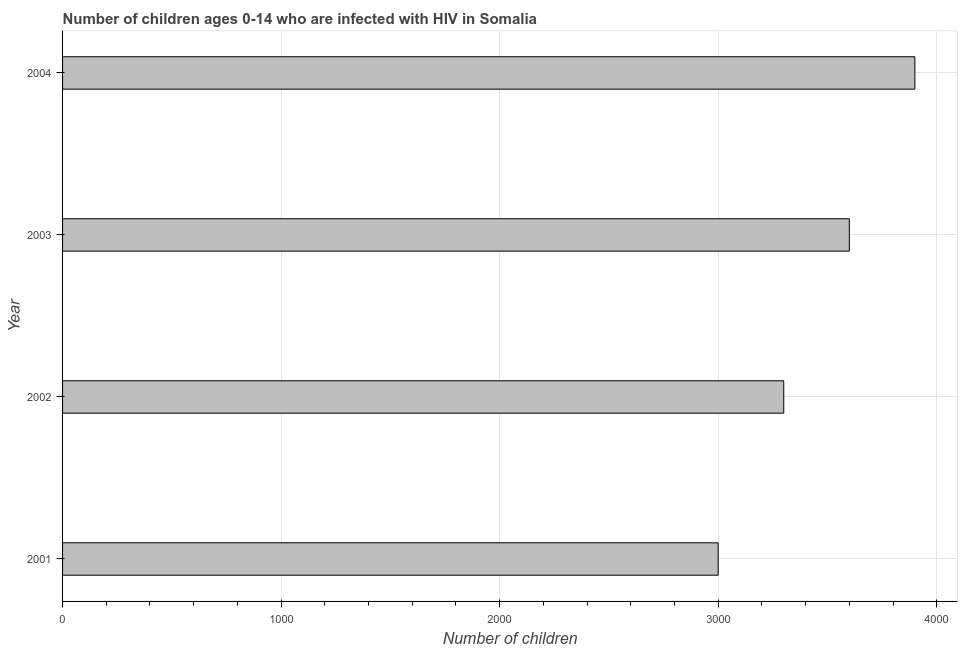Does the graph contain any zero values?
Provide a succinct answer. No. What is the title of the graph?
Ensure brevity in your answer.  Number of children ages 0-14 who are infected with HIV in Somalia. What is the label or title of the X-axis?
Ensure brevity in your answer.  Number of children. What is the label or title of the Y-axis?
Your answer should be compact. Year. What is the number of children living with hiv in 2001?
Keep it short and to the point. 3000. Across all years, what is the maximum number of children living with hiv?
Give a very brief answer. 3900. Across all years, what is the minimum number of children living with hiv?
Keep it short and to the point. 3000. What is the sum of the number of children living with hiv?
Keep it short and to the point. 1.38e+04. What is the difference between the number of children living with hiv in 2001 and 2004?
Give a very brief answer. -900. What is the average number of children living with hiv per year?
Make the answer very short. 3450. What is the median number of children living with hiv?
Ensure brevity in your answer.  3450. In how many years, is the number of children living with hiv greater than 200 ?
Your response must be concise. 4. What is the ratio of the number of children living with hiv in 2001 to that in 2002?
Provide a short and direct response. 0.91. What is the difference between the highest and the second highest number of children living with hiv?
Your answer should be compact. 300. Is the sum of the number of children living with hiv in 2002 and 2003 greater than the maximum number of children living with hiv across all years?
Give a very brief answer. Yes. What is the difference between the highest and the lowest number of children living with hiv?
Make the answer very short. 900. In how many years, is the number of children living with hiv greater than the average number of children living with hiv taken over all years?
Your answer should be very brief. 2. How many bars are there?
Your answer should be very brief. 4. Are all the bars in the graph horizontal?
Offer a terse response. Yes. How many years are there in the graph?
Your answer should be compact. 4. What is the Number of children of 2001?
Make the answer very short. 3000. What is the Number of children of 2002?
Your answer should be compact. 3300. What is the Number of children in 2003?
Give a very brief answer. 3600. What is the Number of children of 2004?
Keep it short and to the point. 3900. What is the difference between the Number of children in 2001 and 2002?
Make the answer very short. -300. What is the difference between the Number of children in 2001 and 2003?
Provide a succinct answer. -600. What is the difference between the Number of children in 2001 and 2004?
Give a very brief answer. -900. What is the difference between the Number of children in 2002 and 2003?
Offer a terse response. -300. What is the difference between the Number of children in 2002 and 2004?
Provide a short and direct response. -600. What is the difference between the Number of children in 2003 and 2004?
Provide a short and direct response. -300. What is the ratio of the Number of children in 2001 to that in 2002?
Your response must be concise. 0.91. What is the ratio of the Number of children in 2001 to that in 2003?
Give a very brief answer. 0.83. What is the ratio of the Number of children in 2001 to that in 2004?
Offer a very short reply. 0.77. What is the ratio of the Number of children in 2002 to that in 2003?
Keep it short and to the point. 0.92. What is the ratio of the Number of children in 2002 to that in 2004?
Your answer should be compact. 0.85. What is the ratio of the Number of children in 2003 to that in 2004?
Offer a very short reply. 0.92. 